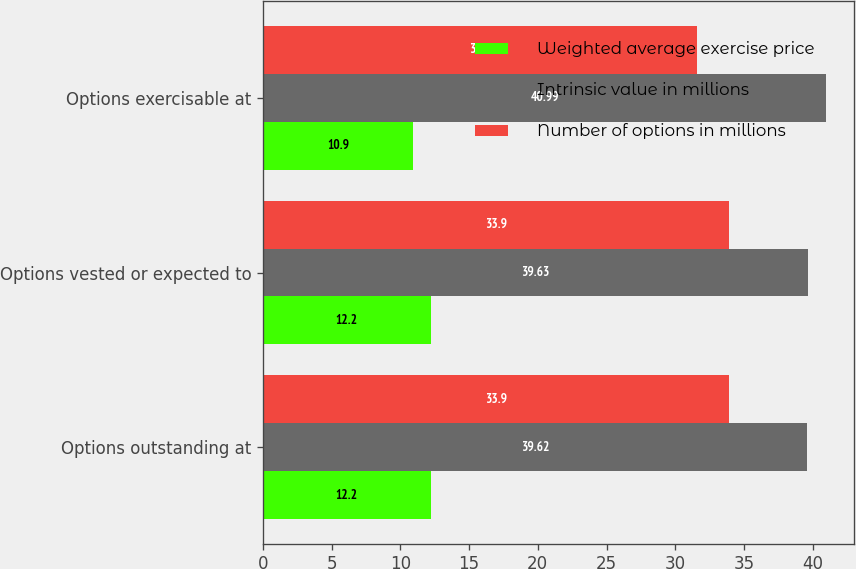<chart> <loc_0><loc_0><loc_500><loc_500><stacked_bar_chart><ecel><fcel>Options outstanding at<fcel>Options vested or expected to<fcel>Options exercisable at<nl><fcel>Weighted average exercise price<fcel>12.2<fcel>12.2<fcel>10.9<nl><fcel>Intrinsic value in millions<fcel>39.62<fcel>39.63<fcel>40.99<nl><fcel>Number of options in millions<fcel>33.9<fcel>33.9<fcel>31.6<nl></chart> 